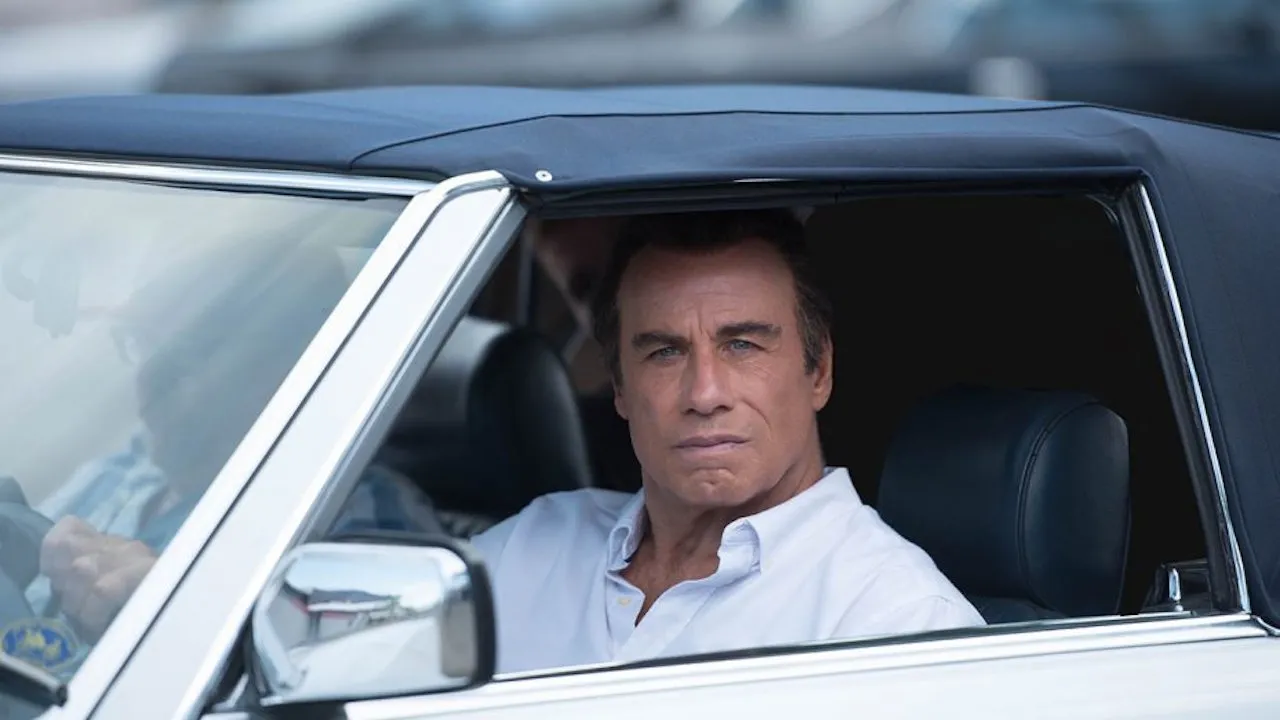What do you think is going on in this snapshot? In the image, a mature man is captured sitting seriously in the driver's seat of a parked, white car. His gaze is directed outside the passenger window, suggesting a moment of deep thought or observation. His attire, a neat white shirt, suggests a formal or semi-formal occasion. The surrounding environment seems busy, potentially a public parking area with other vehicles and visible activity in the background that might indicate a public or crowded place. 